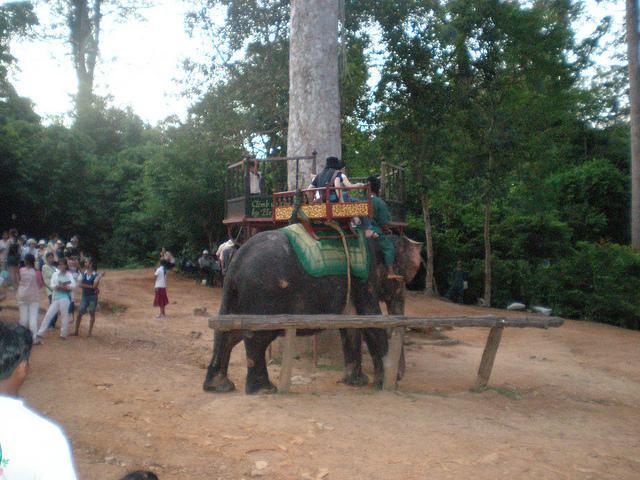How many people are visible?
Give a very brief answer. 2. 